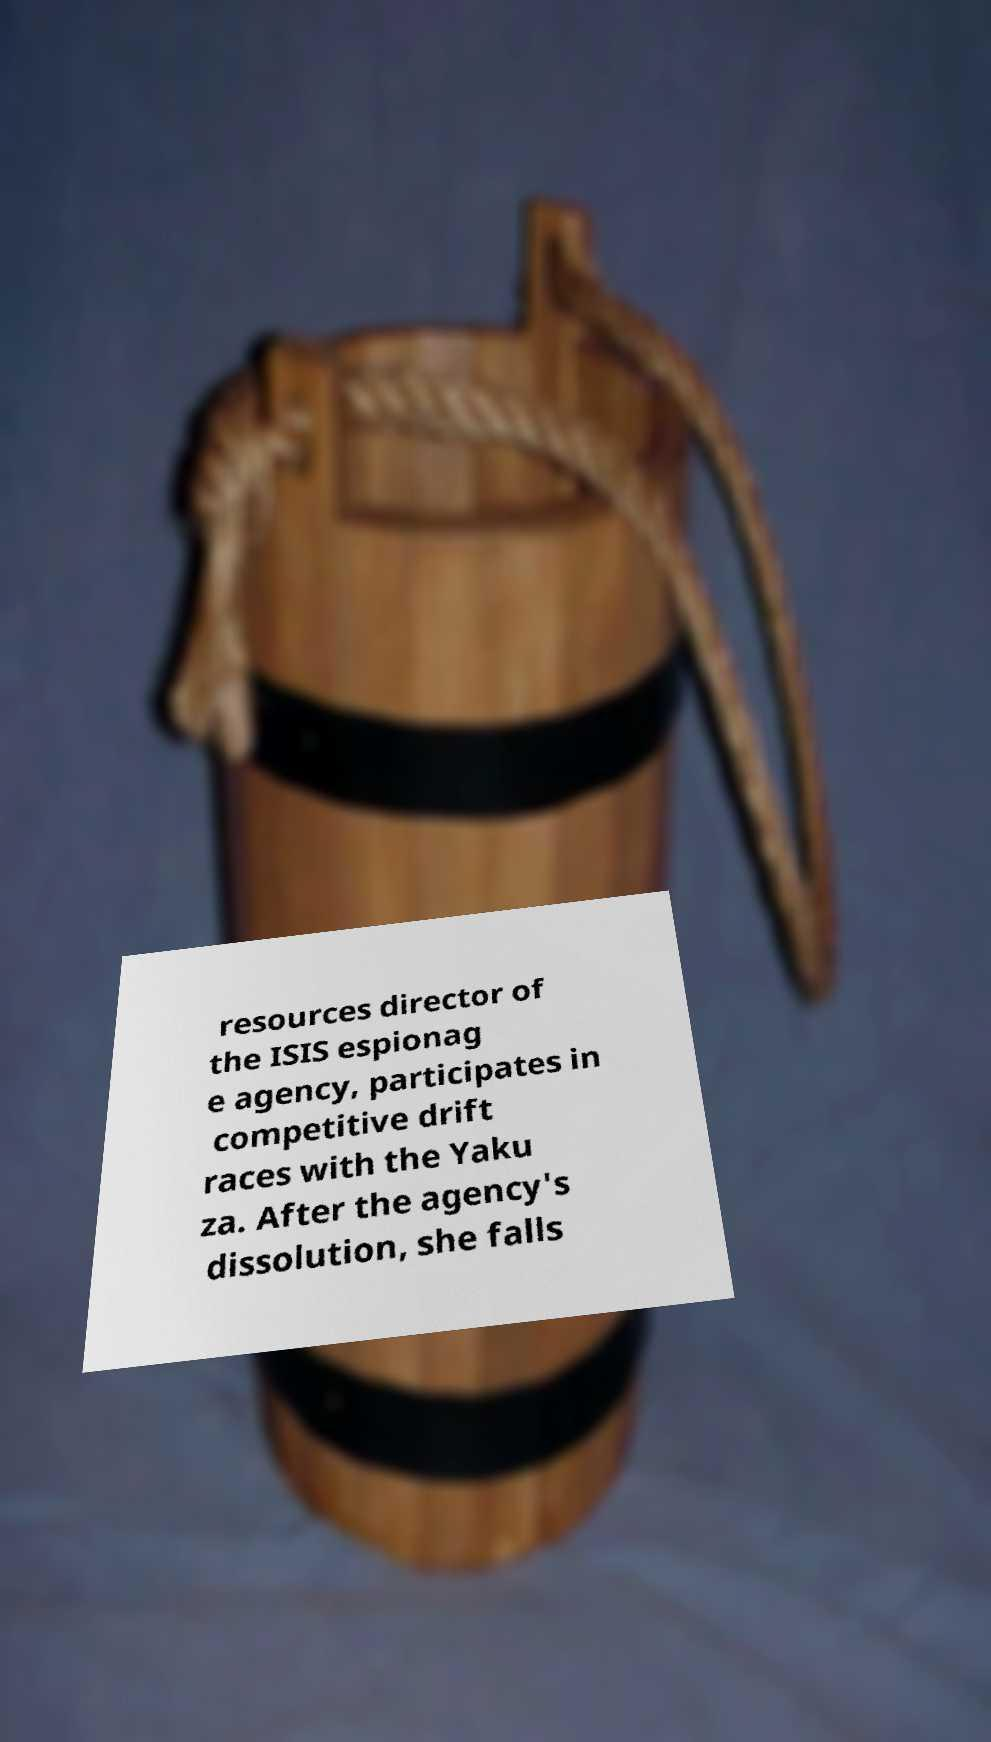There's text embedded in this image that I need extracted. Can you transcribe it verbatim? resources director of the ISIS espionag e agency, participates in competitive drift races with the Yaku za. After the agency's dissolution, she falls 